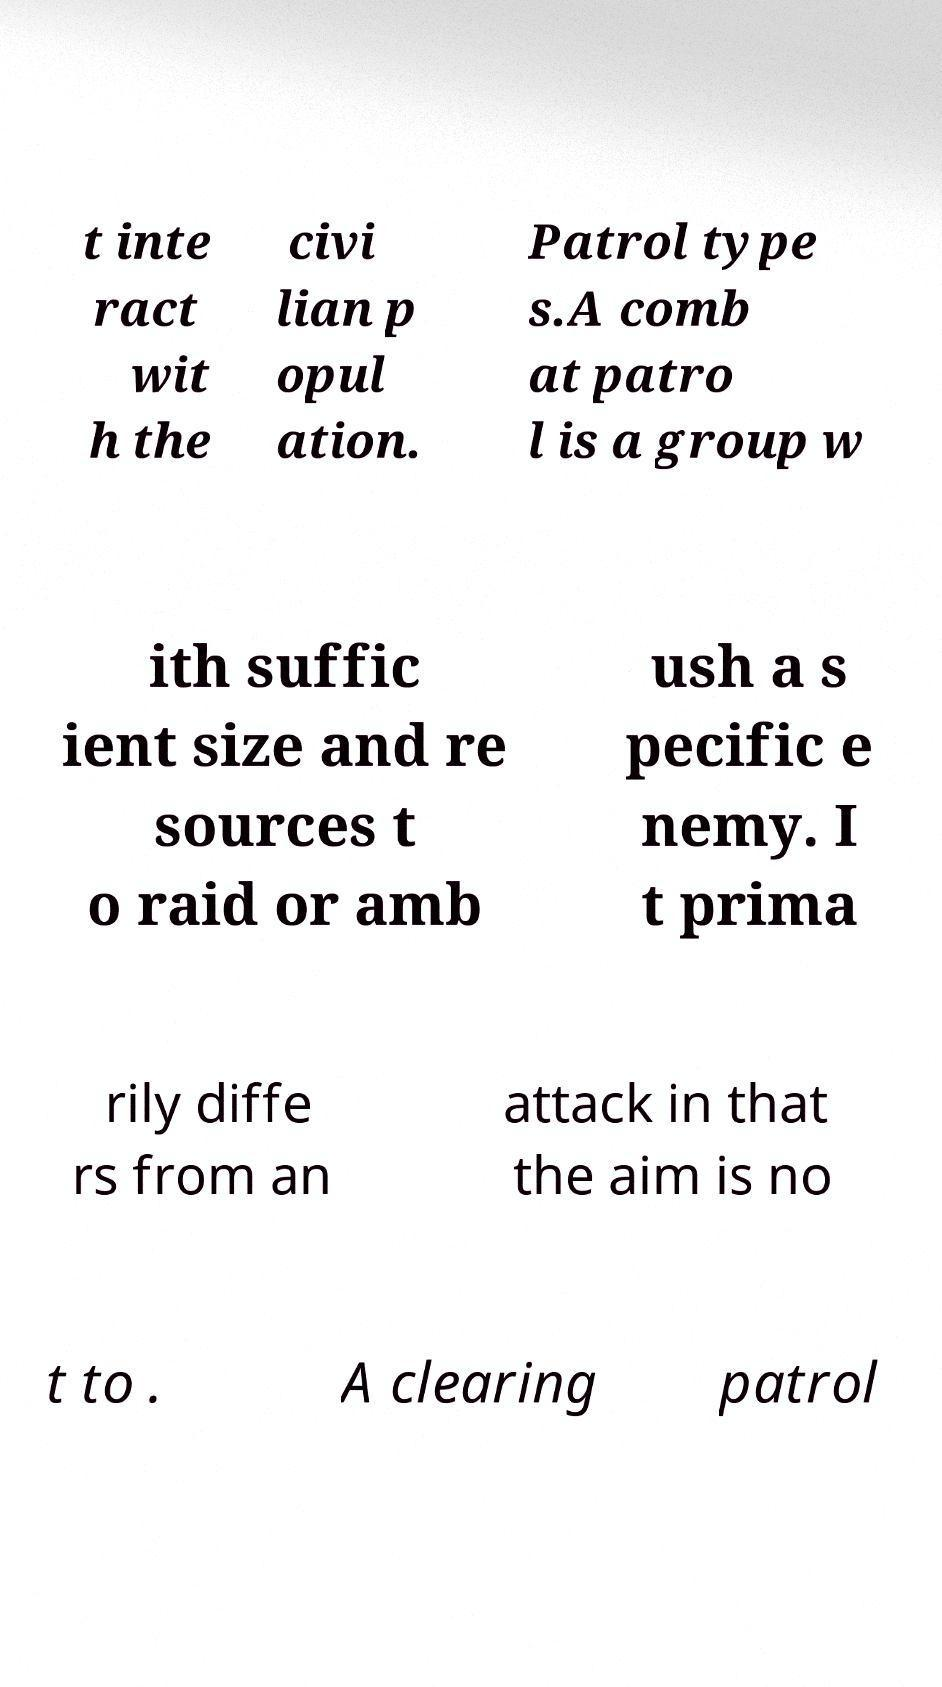What messages or text are displayed in this image? I need them in a readable, typed format. t inte ract wit h the civi lian p opul ation. Patrol type s.A comb at patro l is a group w ith suffic ient size and re sources t o raid or amb ush a s pecific e nemy. I t prima rily diffe rs from an attack in that the aim is no t to . A clearing patrol 